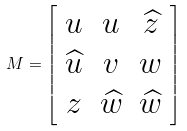<formula> <loc_0><loc_0><loc_500><loc_500>M = \left [ \begin{array} { c c c } { u } & { u } & { { \widehat { z } } } \\ { { \widehat { u } } } & { v } & { w } \\ { z } & { { \widehat { w } } } & { { \widehat { w } } } \end{array} \right ]</formula> 